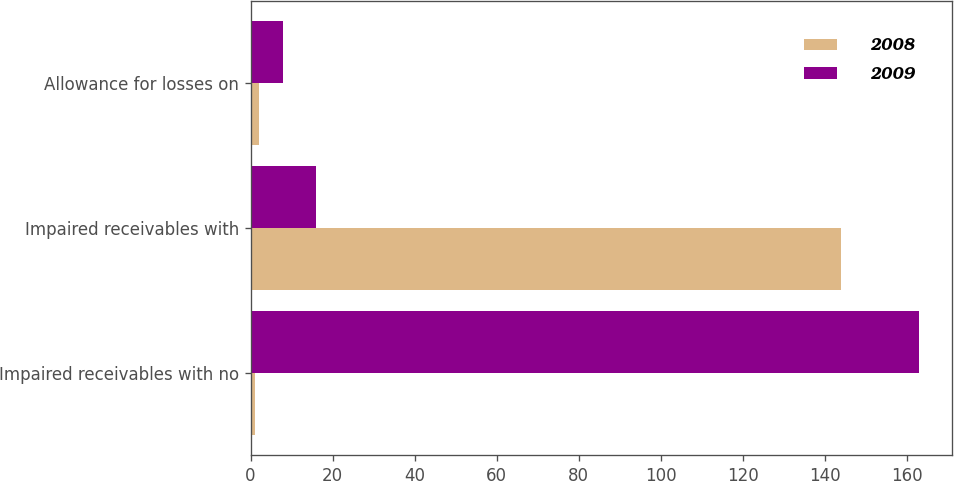Convert chart. <chart><loc_0><loc_0><loc_500><loc_500><stacked_bar_chart><ecel><fcel>Impaired receivables with no<fcel>Impaired receivables with<fcel>Allowance for losses on<nl><fcel>2008<fcel>1<fcel>144<fcel>2<nl><fcel>2009<fcel>163<fcel>16<fcel>8<nl></chart> 